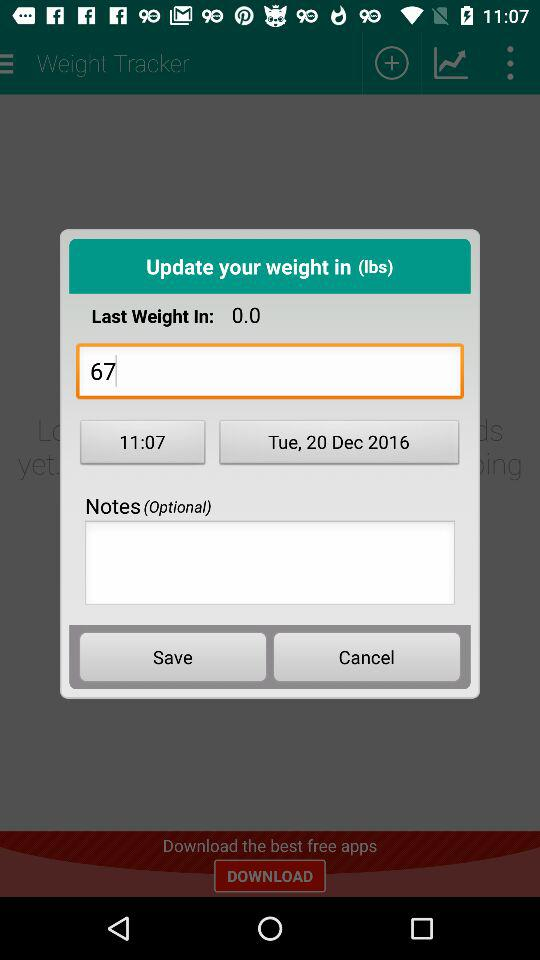What was the last weight? The last weight was 67 lbs. 